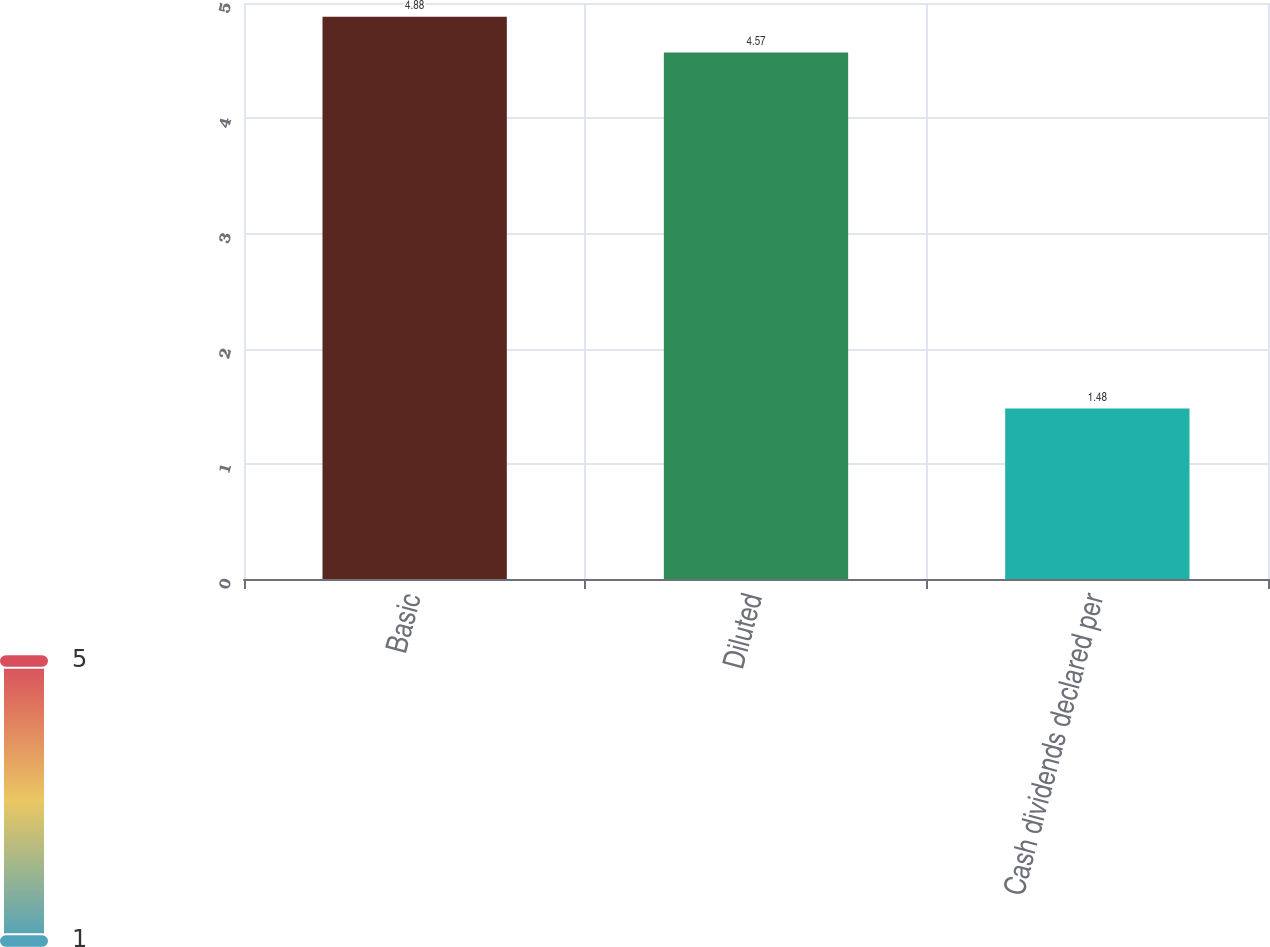Convert chart. <chart><loc_0><loc_0><loc_500><loc_500><bar_chart><fcel>Basic<fcel>Diluted<fcel>Cash dividends declared per<nl><fcel>4.88<fcel>4.57<fcel>1.48<nl></chart> 